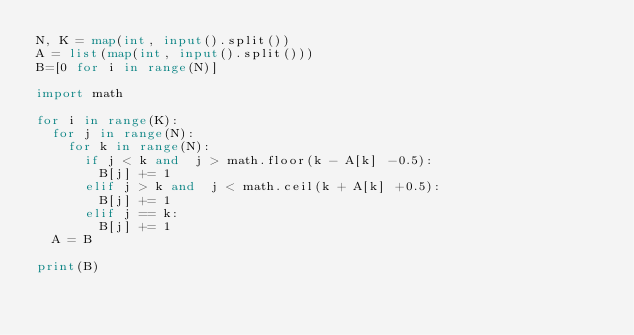Convert code to text. <code><loc_0><loc_0><loc_500><loc_500><_Python_>N, K = map(int, input().split())
A = list(map(int, input().split()))
B=[0 for i in range(N)]

import math
    
for i in range(K):
  for j in range(N):
    for k in range(N):
      if j < k and  j > math.floor(k - A[k] -0.5):
        B[j] += 1
      elif j > k and  j < math.ceil(k + A[k] +0.5):
        B[j] += 1
      elif j == k:
        B[j] += 1
  A = B

print(B)
</code> 